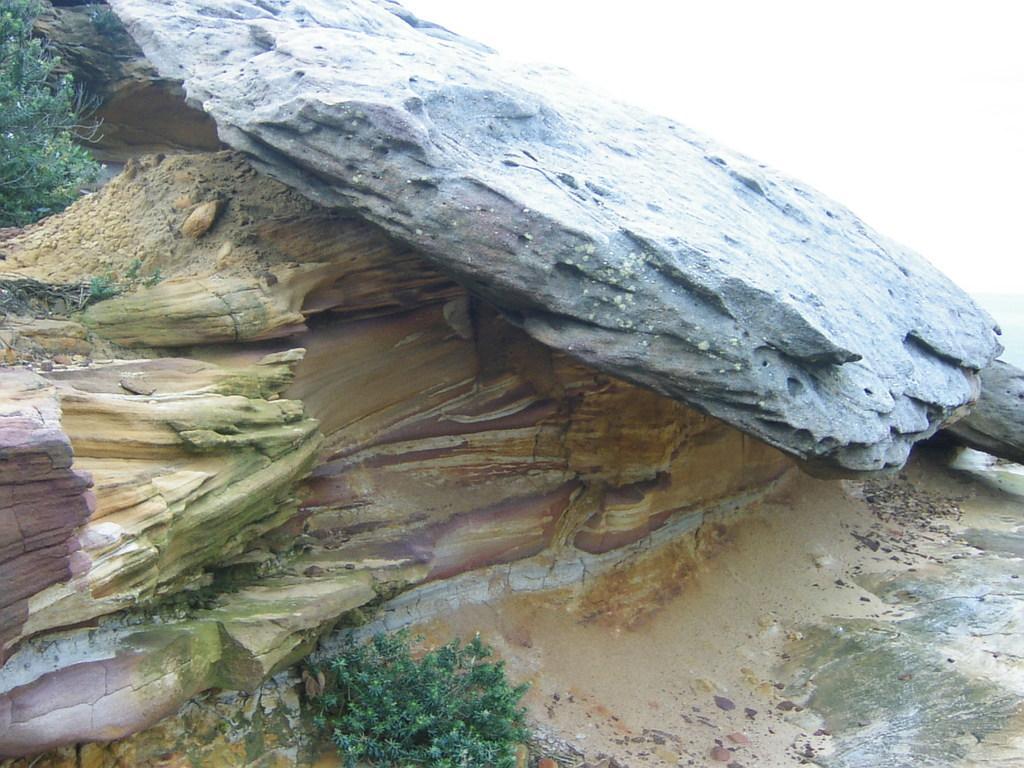Could you give a brief overview of what you see in this image? In this image, we can see the ground with some objects. We can also see some grass, plants. We can also see some rocks and the sky. 